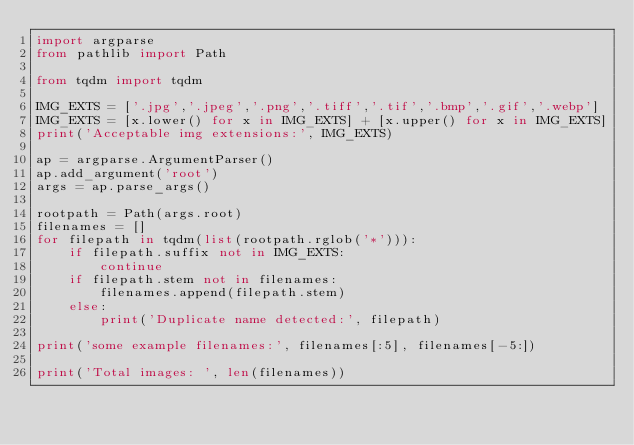Convert code to text. <code><loc_0><loc_0><loc_500><loc_500><_Python_>import argparse
from pathlib import Path

from tqdm import tqdm

IMG_EXTS = ['.jpg','.jpeg','.png','.tiff','.tif','.bmp','.gif','.webp']
IMG_EXTS = [x.lower() for x in IMG_EXTS] + [x.upper() for x in IMG_EXTS]
print('Acceptable img extensions:', IMG_EXTS)

ap = argparse.ArgumentParser()
ap.add_argument('root')
args = ap.parse_args()

rootpath = Path(args.root)
filenames = []
for filepath in tqdm(list(rootpath.rglob('*'))):
    if filepath.suffix not in IMG_EXTS:
        continue
    if filepath.stem not in filenames:
        filenames.append(filepath.stem)
    else:
        print('Duplicate name detected:', filepath)

print('some example filenames:', filenames[:5], filenames[-5:])

print('Total images: ', len(filenames))
</code> 